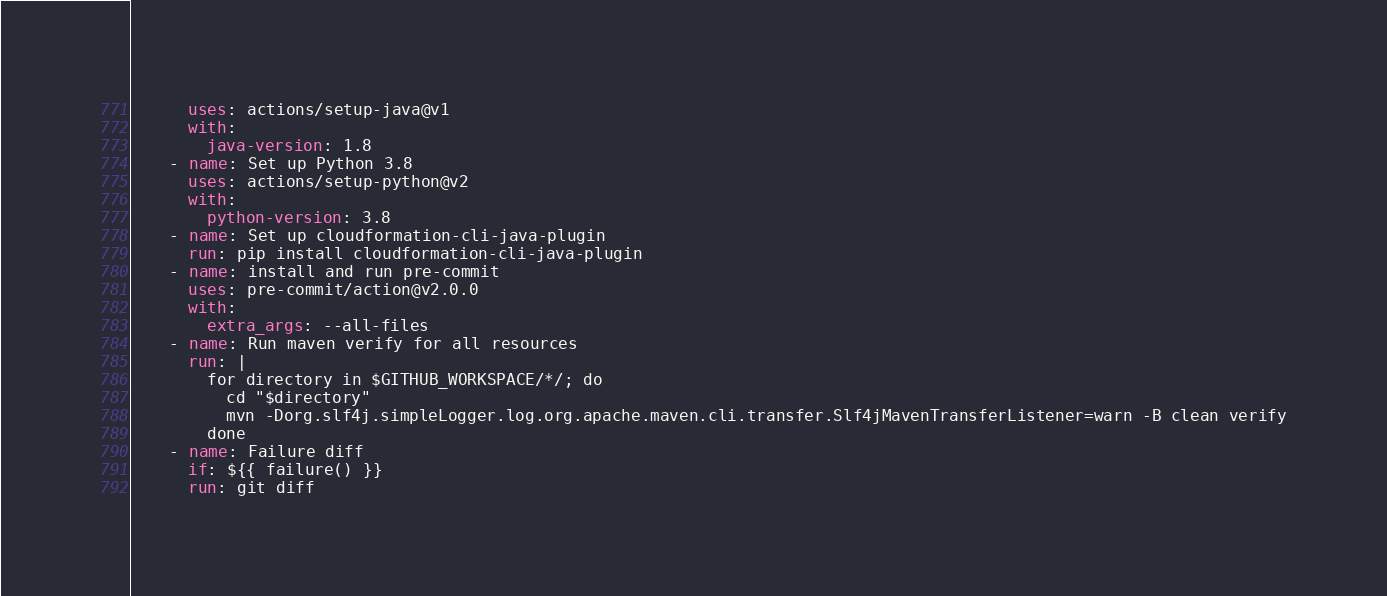<code> <loc_0><loc_0><loc_500><loc_500><_YAML_>      uses: actions/setup-java@v1
      with:
        java-version: 1.8
    - name: Set up Python 3.8
      uses: actions/setup-python@v2
      with:
        python-version: 3.8
    - name: Set up cloudformation-cli-java-plugin
      run: pip install cloudformation-cli-java-plugin
    - name: install and run pre-commit
      uses: pre-commit/action@v2.0.0
      with:
        extra_args: --all-files
    - name: Run maven verify for all resources
      run: |
        for directory in $GITHUB_WORKSPACE/*/; do
          cd "$directory"
          mvn -Dorg.slf4j.simpleLogger.log.org.apache.maven.cli.transfer.Slf4jMavenTransferListener=warn -B clean verify
        done
    - name: Failure diff
      if: ${{ failure() }}
      run: git diff
</code> 